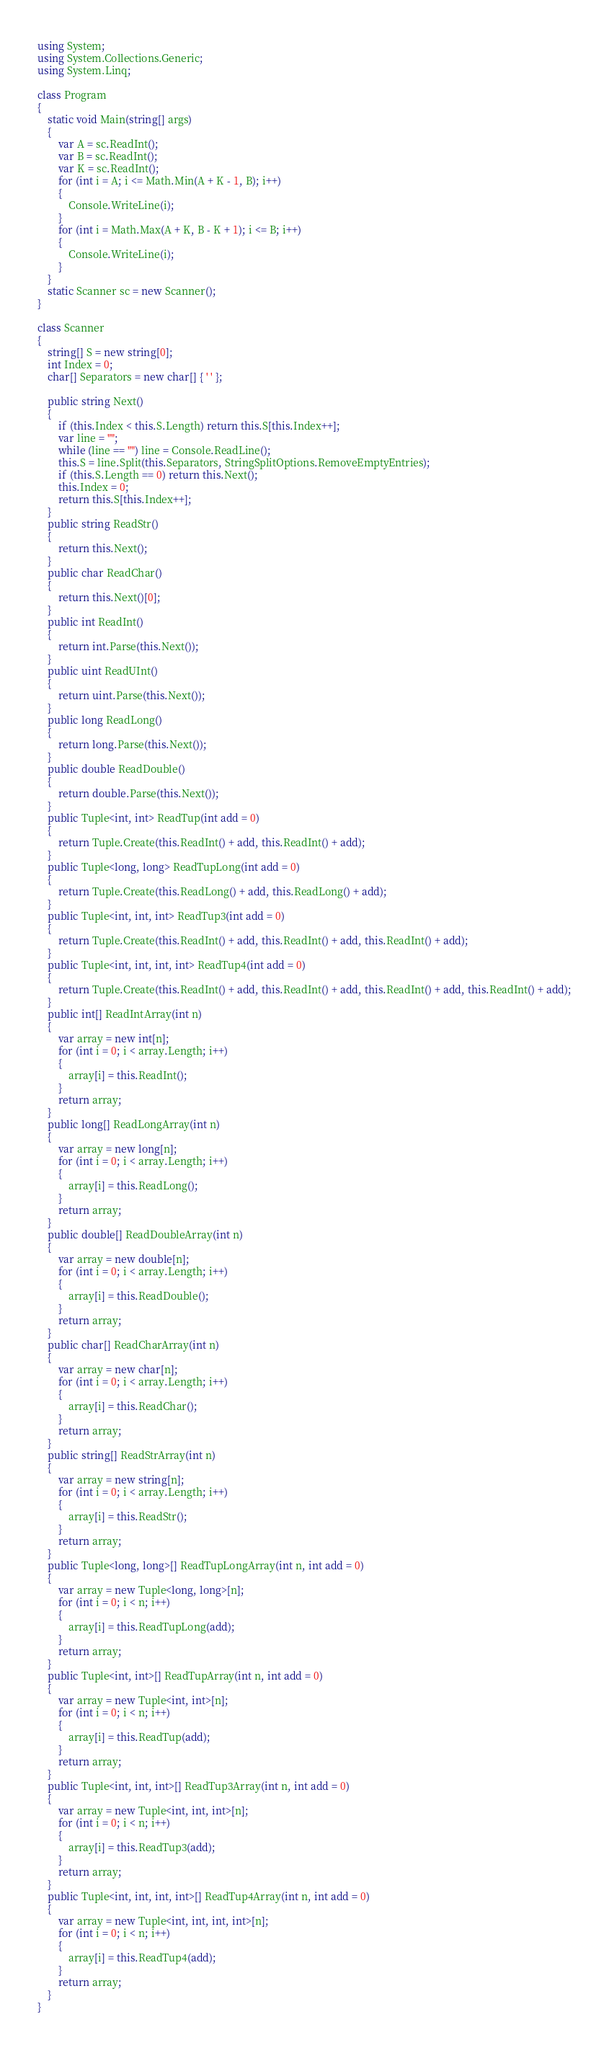<code> <loc_0><loc_0><loc_500><loc_500><_C#_>using System;
using System.Collections.Generic;
using System.Linq;

class Program
{
    static void Main(string[] args)
    {
        var A = sc.ReadInt();
        var B = sc.ReadInt();
        var K = sc.ReadInt();
        for (int i = A; i <= Math.Min(A + K - 1, B); i++)
        {
            Console.WriteLine(i);
        }
        for (int i = Math.Max(A + K, B - K + 1); i <= B; i++)
        {
            Console.WriteLine(i);
        }
    }
    static Scanner sc = new Scanner();
}

class Scanner
{
    string[] S = new string[0];
    int Index = 0;
    char[] Separators = new char[] { ' ' };

    public string Next()
    {
        if (this.Index < this.S.Length) return this.S[this.Index++];
        var line = "";
        while (line == "") line = Console.ReadLine();
        this.S = line.Split(this.Separators, StringSplitOptions.RemoveEmptyEntries);
        if (this.S.Length == 0) return this.Next();
        this.Index = 0;
        return this.S[this.Index++];
    }
    public string ReadStr()
    {
        return this.Next();
    }
    public char ReadChar()
    {
        return this.Next()[0];
    }
    public int ReadInt()
    {
        return int.Parse(this.Next());
    }
    public uint ReadUInt()
    {
        return uint.Parse(this.Next());
    }
    public long ReadLong()
    {
        return long.Parse(this.Next());
    }
    public double ReadDouble()
    {
        return double.Parse(this.Next());
    }
    public Tuple<int, int> ReadTup(int add = 0)
    {
        return Tuple.Create(this.ReadInt() + add, this.ReadInt() + add);
    }
    public Tuple<long, long> ReadTupLong(int add = 0)
    {
        return Tuple.Create(this.ReadLong() + add, this.ReadLong() + add);
    }
    public Tuple<int, int, int> ReadTup3(int add = 0)
    {
        return Tuple.Create(this.ReadInt() + add, this.ReadInt() + add, this.ReadInt() + add);
    }
    public Tuple<int, int, int, int> ReadTup4(int add = 0)
    {
        return Tuple.Create(this.ReadInt() + add, this.ReadInt() + add, this.ReadInt() + add, this.ReadInt() + add);
    }
    public int[] ReadIntArray(int n)
    {
        var array = new int[n];
        for (int i = 0; i < array.Length; i++)
        {
            array[i] = this.ReadInt();
        }
        return array;
    }
    public long[] ReadLongArray(int n)
    {
        var array = new long[n];
        for (int i = 0; i < array.Length; i++)
        {
            array[i] = this.ReadLong();
        }
        return array;
    }
    public double[] ReadDoubleArray(int n)
    {
        var array = new double[n];
        for (int i = 0; i < array.Length; i++)
        {
            array[i] = this.ReadDouble();
        }
        return array;
    }
    public char[] ReadCharArray(int n)
    {
        var array = new char[n];
        for (int i = 0; i < array.Length; i++)
        {
            array[i] = this.ReadChar();
        }
        return array;
    }
    public string[] ReadStrArray(int n)
    {
        var array = new string[n];
        for (int i = 0; i < array.Length; i++)
        {
            array[i] = this.ReadStr();
        }
        return array;
    }
    public Tuple<long, long>[] ReadTupLongArray(int n, int add = 0)
    {
        var array = new Tuple<long, long>[n];
        for (int i = 0; i < n; i++)
        {
            array[i] = this.ReadTupLong(add);
        }
        return array;
    }
    public Tuple<int, int>[] ReadTupArray(int n, int add = 0)
    {
        var array = new Tuple<int, int>[n];
        for (int i = 0; i < n; i++)
        {
            array[i] = this.ReadTup(add);
        }
        return array;
    }
    public Tuple<int, int, int>[] ReadTup3Array(int n, int add = 0)
    {
        var array = new Tuple<int, int, int>[n];
        for (int i = 0; i < n; i++)
        {
            array[i] = this.ReadTup3(add);
        }
        return array;
    }
    public Tuple<int, int, int, int>[] ReadTup4Array(int n, int add = 0)
    {
        var array = new Tuple<int, int, int, int>[n];
        for (int i = 0; i < n; i++)
        {
            array[i] = this.ReadTup4(add);
        }
        return array;
    }
}
</code> 